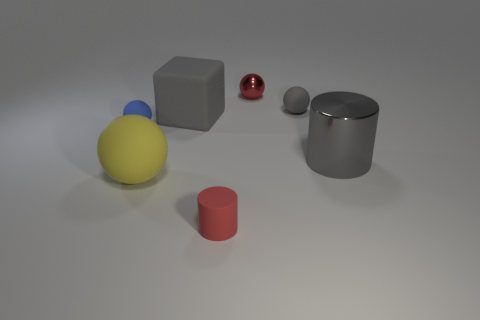What material is the small red thing behind the gray cylinder?
Provide a succinct answer. Metal. Does the red object behind the small gray rubber object have the same material as the large gray cylinder?
Offer a terse response. Yes. Are there any blue metallic cubes?
Keep it short and to the point. No. What is the color of the tiny cylinder that is the same material as the large yellow object?
Ensure brevity in your answer.  Red. There is a tiny thing behind the tiny matte ball behind the small thing left of the big gray matte object; what color is it?
Ensure brevity in your answer.  Red. Does the gray matte block have the same size as the rubber ball behind the block?
Offer a very short reply. No. How many things are either rubber objects to the right of the tiny metal ball or gray objects that are behind the gray metallic cylinder?
Provide a succinct answer. 2. What is the shape of the rubber thing that is the same size as the gray rubber cube?
Offer a terse response. Sphere. There is a tiny rubber thing to the left of the big rubber block left of the cylinder to the right of the red metal object; what shape is it?
Provide a succinct answer. Sphere. Are there an equal number of big yellow rubber things on the left side of the yellow rubber ball and rubber spheres?
Keep it short and to the point. No. 